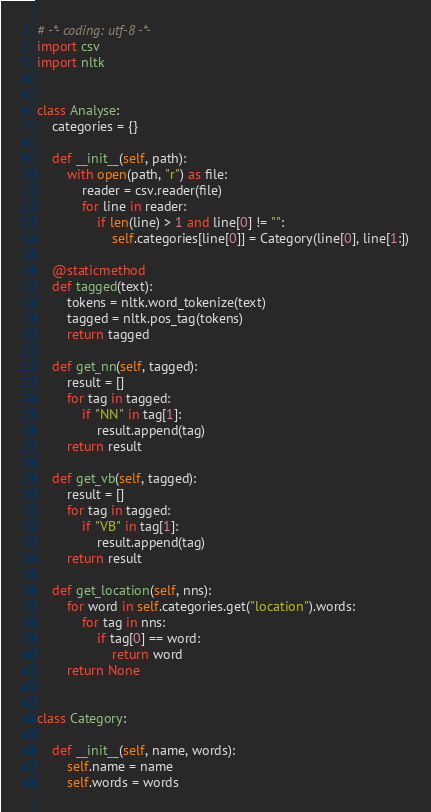Convert code to text. <code><loc_0><loc_0><loc_500><loc_500><_Python_># -*- coding: utf-8 -*-
import csv
import nltk


class Analyse:
    categories = {}

    def __init__(self, path):
        with open(path, "r") as file:
            reader = csv.reader(file)
            for line in reader:
                if len(line) > 1 and line[0] != "":
                    self.categories[line[0]] = Category(line[0], line[1:])

    @staticmethod
    def tagged(text):
        tokens = nltk.word_tokenize(text)
        tagged = nltk.pos_tag(tokens)
        return tagged

    def get_nn(self, tagged):
        result = []
        for tag in tagged:
            if "NN" in tag[1]:
                result.append(tag)
        return result

    def get_vb(self, tagged):
        result = []
        for tag in tagged:
            if "VB" in tag[1]:
                result.append(tag)
        return result

    def get_location(self, nns):
        for word in self.categories.get("location").words:
            for tag in nns:
                if tag[0] == word:
                    return word
        return None


class Category:

    def __init__(self, name, words):
        self.name = name
        self.words = words
</code> 